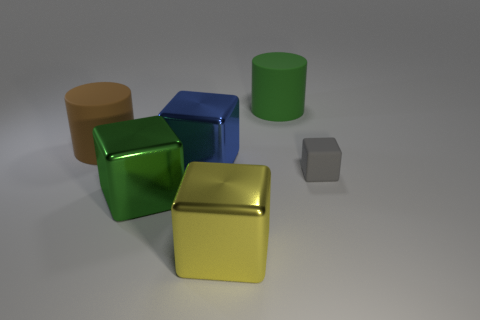Subtract all green cubes. How many cubes are left? 3 Subtract all green cylinders. How many cylinders are left? 1 Add 3 big green cylinders. How many objects exist? 9 Subtract all blocks. How many objects are left? 2 Subtract 1 cylinders. How many cylinders are left? 1 Subtract all red blocks. Subtract all brown spheres. How many blocks are left? 4 Subtract all large shiny cubes. Subtract all large brown matte cylinders. How many objects are left? 2 Add 1 big yellow cubes. How many big yellow cubes are left? 2 Add 3 rubber blocks. How many rubber blocks exist? 4 Subtract 0 brown cubes. How many objects are left? 6 